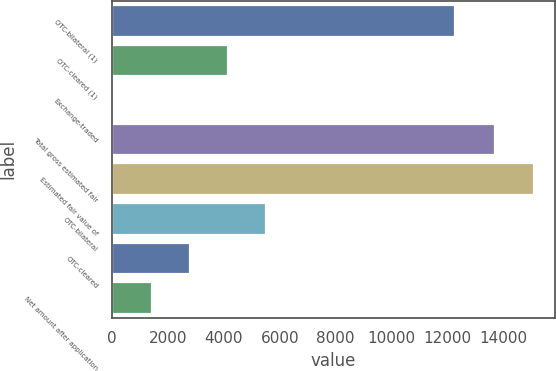Convert chart. <chart><loc_0><loc_0><loc_500><loc_500><bar_chart><fcel>OTC-bilateral (1)<fcel>OTC-cleared (1)<fcel>Exchange-traded<fcel>Total gross estimated fair<fcel>Estimated fair value of<fcel>OTC-bilateral<fcel>OTC-cleared<fcel>Net amount after application<nl><fcel>12256<fcel>4161.8<fcel>71<fcel>13707<fcel>15070.6<fcel>5525.4<fcel>2798.2<fcel>1434.6<nl></chart> 